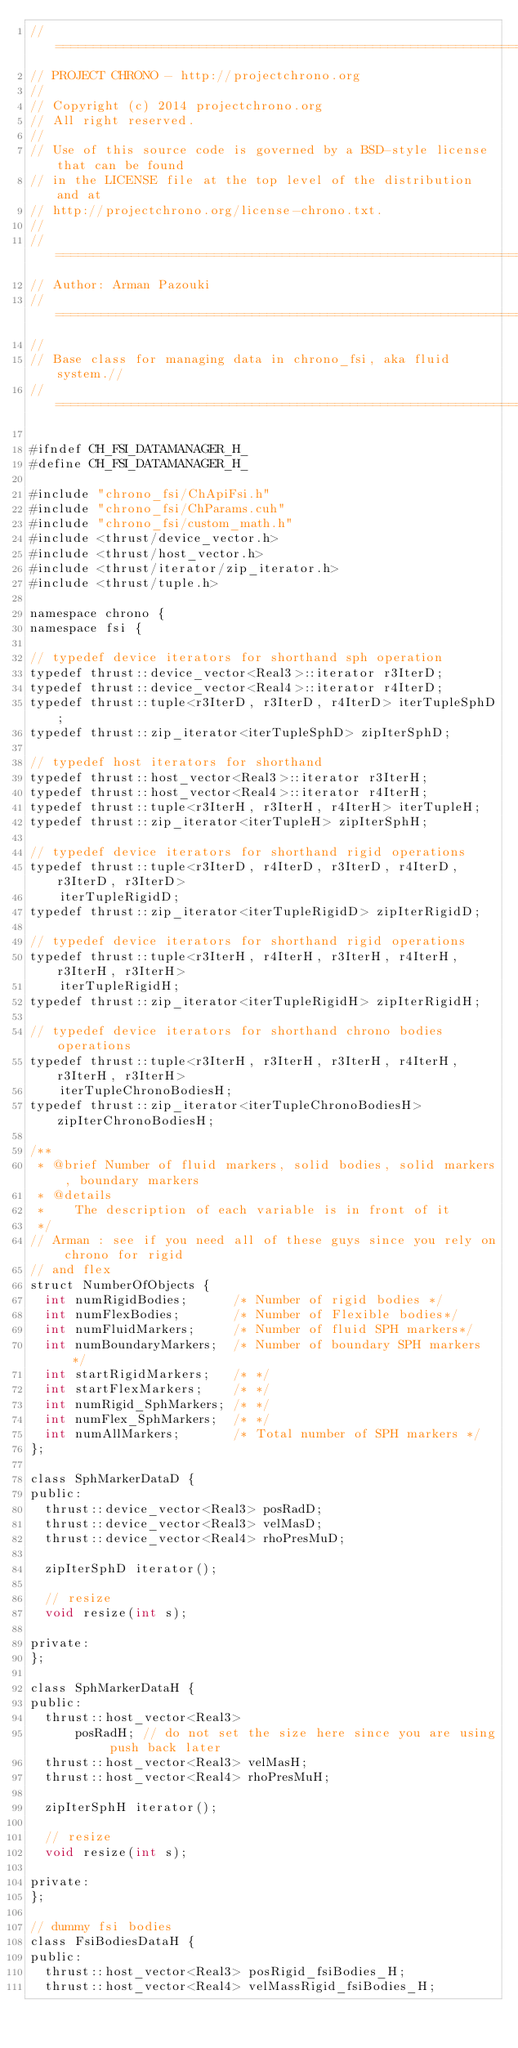<code> <loc_0><loc_0><loc_500><loc_500><_Cuda_>// =============================================================================
// PROJECT CHRONO - http://projectchrono.org
//
// Copyright (c) 2014 projectchrono.org
// All right reserved.
//
// Use of this source code is governed by a BSD-style license that can be found
// in the LICENSE file at the top level of the distribution and at
// http://projectchrono.org/license-chrono.txt.
//
// =============================================================================
// Author: Arman Pazouki
// =============================================================================
//
// Base class for managing data in chrono_fsi, aka fluid system.//
// =============================================================================

#ifndef CH_FSI_DATAMANAGER_H_
#define CH_FSI_DATAMANAGER_H_

#include "chrono_fsi/ChApiFsi.h"
#include "chrono_fsi/ChParams.cuh"
#include "chrono_fsi/custom_math.h"
#include <thrust/device_vector.h>
#include <thrust/host_vector.h>
#include <thrust/iterator/zip_iterator.h>
#include <thrust/tuple.h>

namespace chrono {
namespace fsi {

// typedef device iterators for shorthand sph operation
typedef thrust::device_vector<Real3>::iterator r3IterD;
typedef thrust::device_vector<Real4>::iterator r4IterD;
typedef thrust::tuple<r3IterD, r3IterD, r4IterD> iterTupleSphD;
typedef thrust::zip_iterator<iterTupleSphD> zipIterSphD;

// typedef host iterators for shorthand
typedef thrust::host_vector<Real3>::iterator r3IterH;
typedef thrust::host_vector<Real4>::iterator r4IterH;
typedef thrust::tuple<r3IterH, r3IterH, r4IterH> iterTupleH;
typedef thrust::zip_iterator<iterTupleH> zipIterSphH;

// typedef device iterators for shorthand rigid operations
typedef thrust::tuple<r3IterD, r4IterD, r3IterD, r4IterD, r3IterD, r3IterD>
    iterTupleRigidD;
typedef thrust::zip_iterator<iterTupleRigidD> zipIterRigidD;

// typedef device iterators for shorthand rigid operations
typedef thrust::tuple<r3IterH, r4IterH, r3IterH, r4IterH, r3IterH, r3IterH>
    iterTupleRigidH;
typedef thrust::zip_iterator<iterTupleRigidH> zipIterRigidH;

// typedef device iterators for shorthand chrono bodies operations
typedef thrust::tuple<r3IterH, r3IterH, r3IterH, r4IterH, r3IterH, r3IterH>
    iterTupleChronoBodiesH;
typedef thrust::zip_iterator<iterTupleChronoBodiesH> zipIterChronoBodiesH;

/**
 * @brief Number of fluid markers, solid bodies, solid markers, boundary markers
 * @details
 * 		The description of each variable is in front of it
 */
// Arman : see if you need all of these guys since you rely on chrono for rigid
// and flex
struct NumberOfObjects {
  int numRigidBodies;      /* Number of rigid bodies */
  int numFlexBodies;       /* Number of Flexible bodies*/
  int numFluidMarkers;     /* Number of fluid SPH markers*/
  int numBoundaryMarkers;  /* Number of boundary SPH markers */
  int startRigidMarkers;   /* */
  int startFlexMarkers;    /* */
  int numRigid_SphMarkers; /* */
  int numFlex_SphMarkers;  /* */
  int numAllMarkers;       /* Total number of SPH markers */
};

class SphMarkerDataD {
public:
  thrust::device_vector<Real3> posRadD;
  thrust::device_vector<Real3> velMasD;
  thrust::device_vector<Real4> rhoPresMuD;

  zipIterSphD iterator();

  // resize
  void resize(int s);

private:
};

class SphMarkerDataH {
public:
  thrust::host_vector<Real3>
      posRadH; // do not set the size here since you are using push back later
  thrust::host_vector<Real3> velMasH;
  thrust::host_vector<Real4> rhoPresMuH;

  zipIterSphH iterator();

  // resize
  void resize(int s);

private:
};

// dummy fsi bodies
class FsiBodiesDataH {
public:
  thrust::host_vector<Real3> posRigid_fsiBodies_H;
  thrust::host_vector<Real4> velMassRigid_fsiBodies_H;</code> 